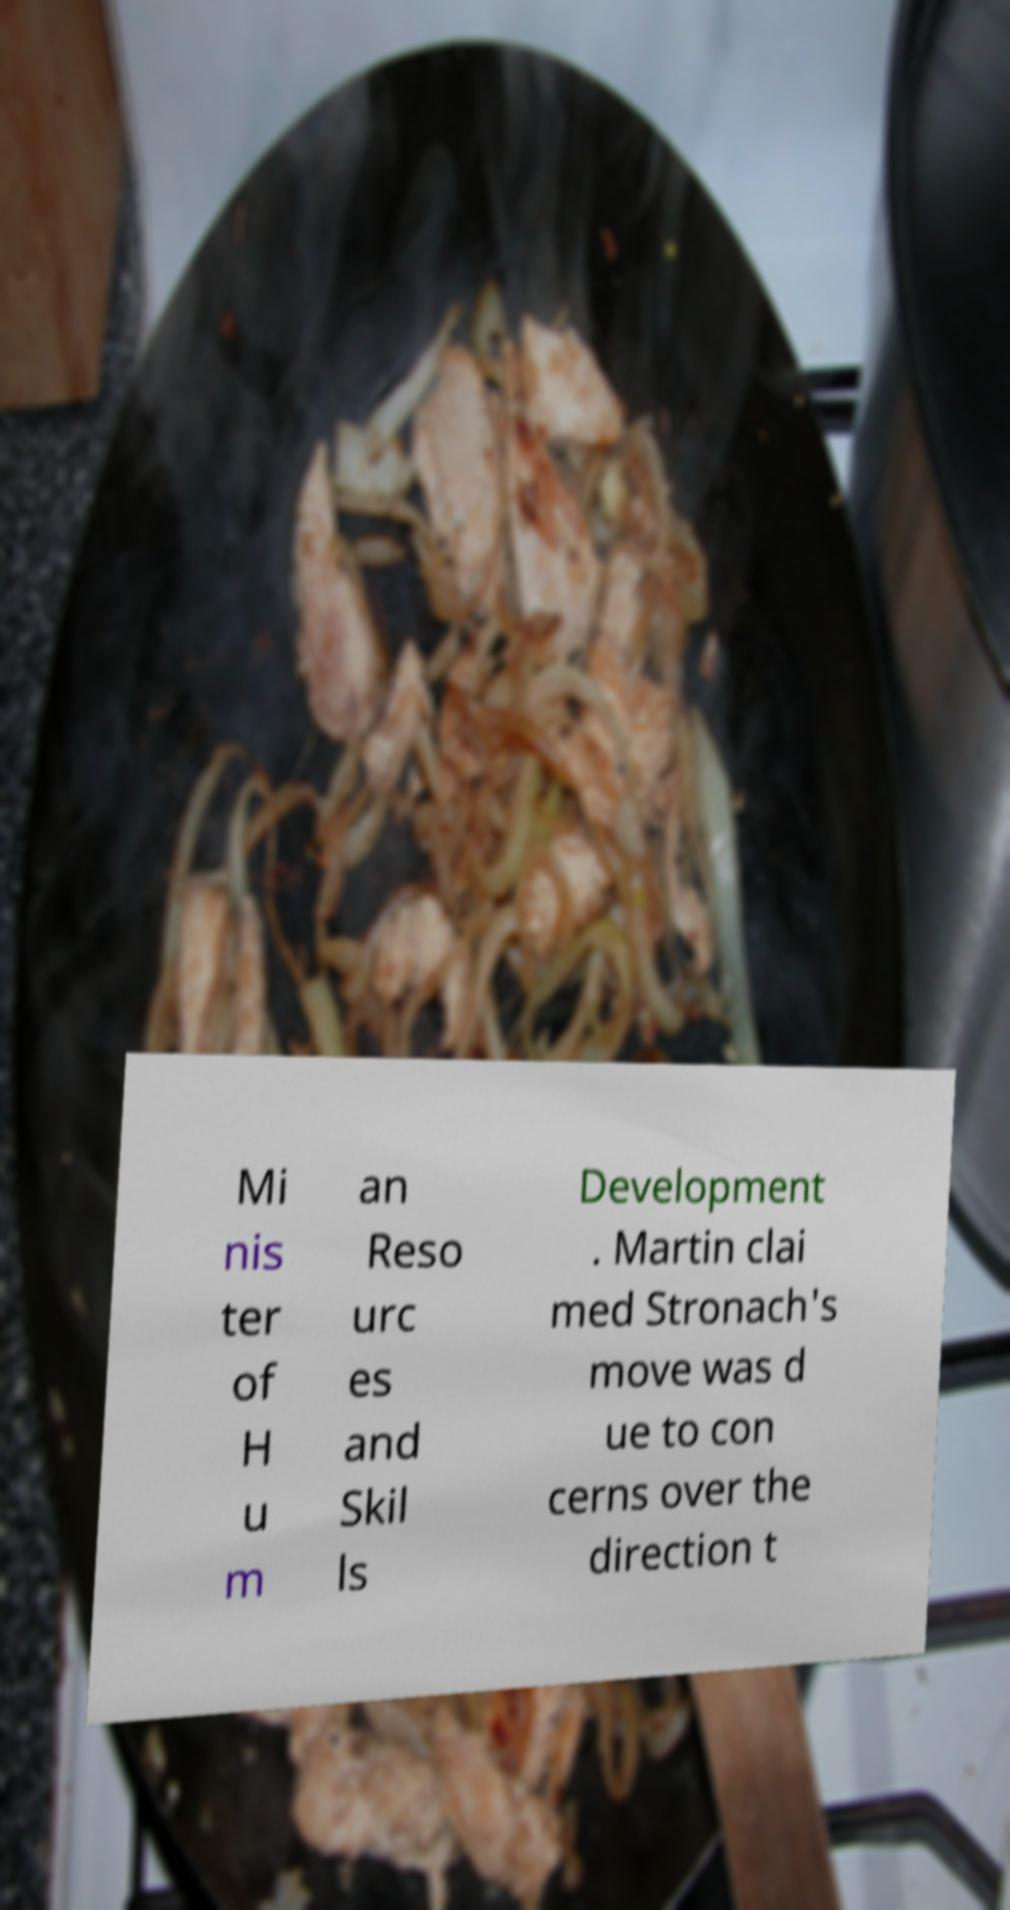Please read and relay the text visible in this image. What does it say? Mi nis ter of H u m an Reso urc es and Skil ls Development . Martin clai med Stronach's move was d ue to con cerns over the direction t 